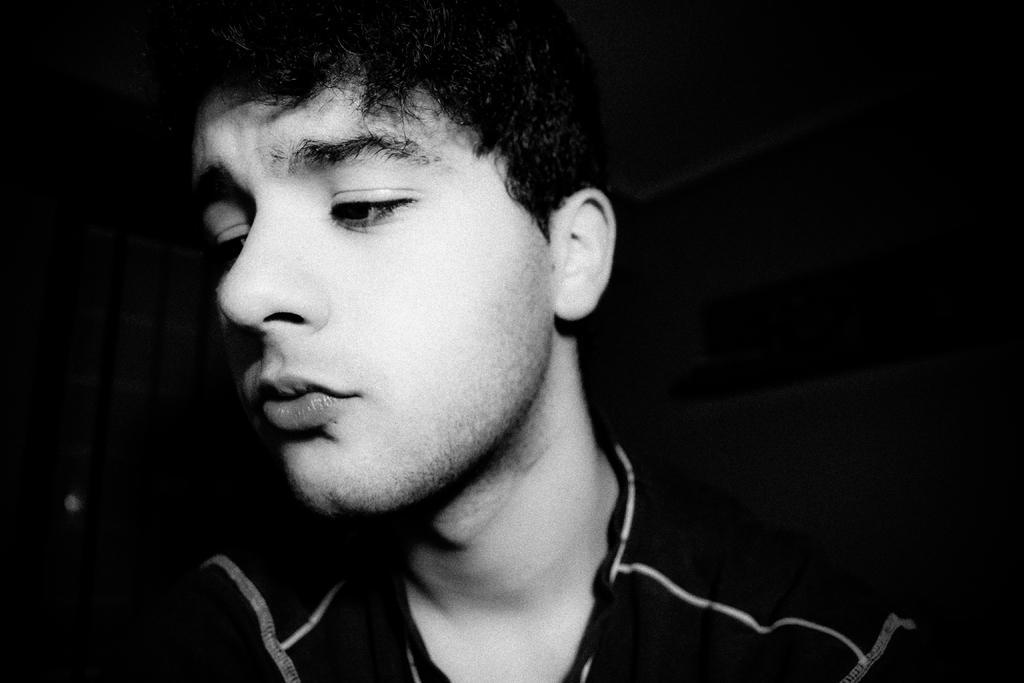Please provide a concise description of this image. In the foreground of this black and white image, there is a man in the dark. 